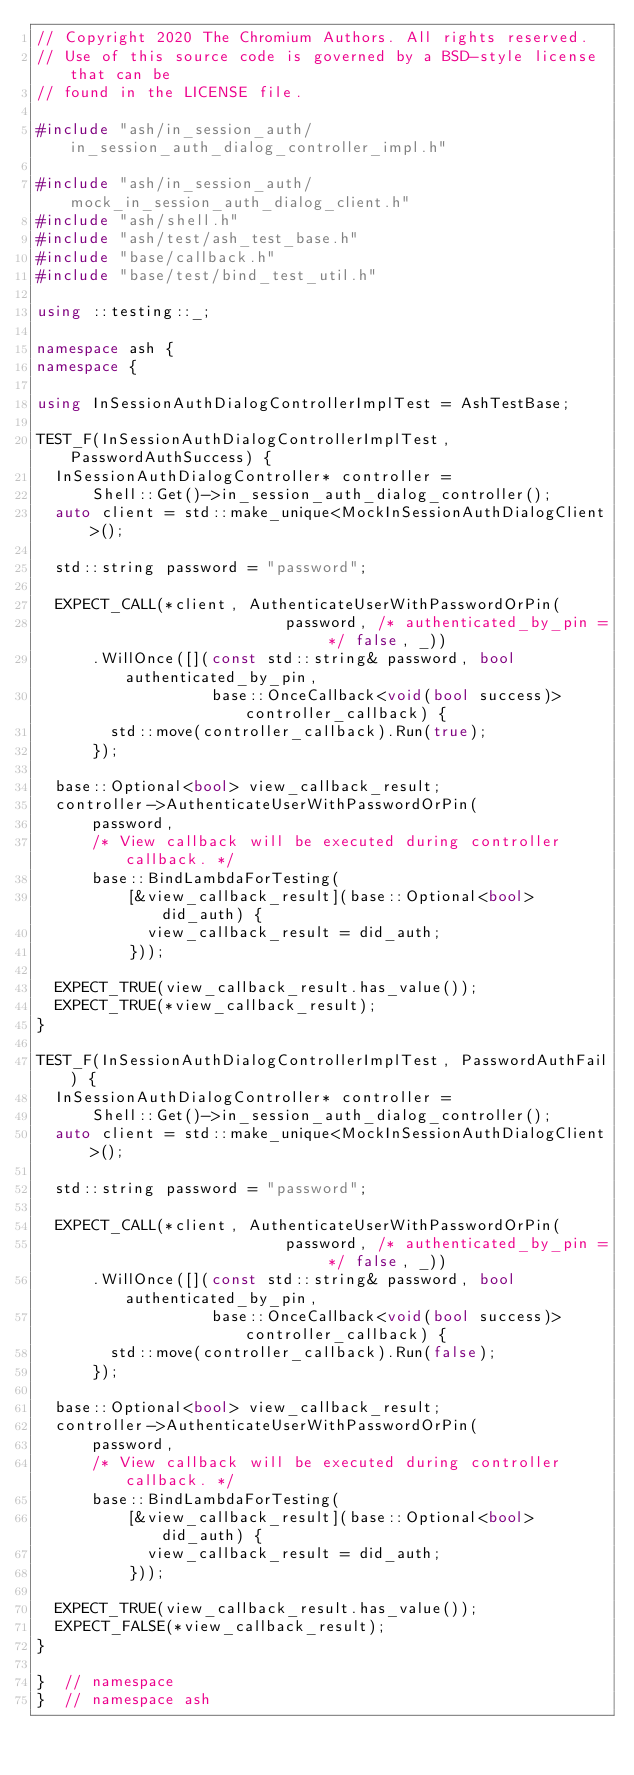<code> <loc_0><loc_0><loc_500><loc_500><_C++_>// Copyright 2020 The Chromium Authors. All rights reserved.
// Use of this source code is governed by a BSD-style license that can be
// found in the LICENSE file.

#include "ash/in_session_auth/in_session_auth_dialog_controller_impl.h"

#include "ash/in_session_auth/mock_in_session_auth_dialog_client.h"
#include "ash/shell.h"
#include "ash/test/ash_test_base.h"
#include "base/callback.h"
#include "base/test/bind_test_util.h"

using ::testing::_;

namespace ash {
namespace {

using InSessionAuthDialogControllerImplTest = AshTestBase;

TEST_F(InSessionAuthDialogControllerImplTest, PasswordAuthSuccess) {
  InSessionAuthDialogController* controller =
      Shell::Get()->in_session_auth_dialog_controller();
  auto client = std::make_unique<MockInSessionAuthDialogClient>();

  std::string password = "password";

  EXPECT_CALL(*client, AuthenticateUserWithPasswordOrPin(
                           password, /* authenticated_by_pin = */ false, _))
      .WillOnce([](const std::string& password, bool authenticated_by_pin,
                   base::OnceCallback<void(bool success)> controller_callback) {
        std::move(controller_callback).Run(true);
      });

  base::Optional<bool> view_callback_result;
  controller->AuthenticateUserWithPasswordOrPin(
      password,
      /* View callback will be executed during controller callback. */
      base::BindLambdaForTesting(
          [&view_callback_result](base::Optional<bool> did_auth) {
            view_callback_result = did_auth;
          }));

  EXPECT_TRUE(view_callback_result.has_value());
  EXPECT_TRUE(*view_callback_result);
}

TEST_F(InSessionAuthDialogControllerImplTest, PasswordAuthFail) {
  InSessionAuthDialogController* controller =
      Shell::Get()->in_session_auth_dialog_controller();
  auto client = std::make_unique<MockInSessionAuthDialogClient>();

  std::string password = "password";

  EXPECT_CALL(*client, AuthenticateUserWithPasswordOrPin(
                           password, /* authenticated_by_pin = */ false, _))
      .WillOnce([](const std::string& password, bool authenticated_by_pin,
                   base::OnceCallback<void(bool success)> controller_callback) {
        std::move(controller_callback).Run(false);
      });

  base::Optional<bool> view_callback_result;
  controller->AuthenticateUserWithPasswordOrPin(
      password,
      /* View callback will be executed during controller callback. */
      base::BindLambdaForTesting(
          [&view_callback_result](base::Optional<bool> did_auth) {
            view_callback_result = did_auth;
          }));

  EXPECT_TRUE(view_callback_result.has_value());
  EXPECT_FALSE(*view_callback_result);
}

}  // namespace
}  // namespace ash
</code> 